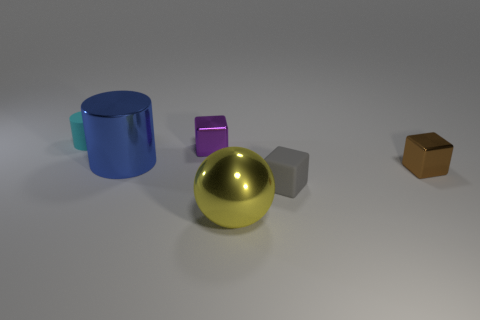Add 2 cyan cylinders. How many objects exist? 8 Subtract all cylinders. How many objects are left? 4 Add 5 large things. How many large things are left? 7 Add 4 blue metallic things. How many blue metallic things exist? 5 Subtract 0 brown cylinders. How many objects are left? 6 Subtract all large things. Subtract all gray rubber cubes. How many objects are left? 3 